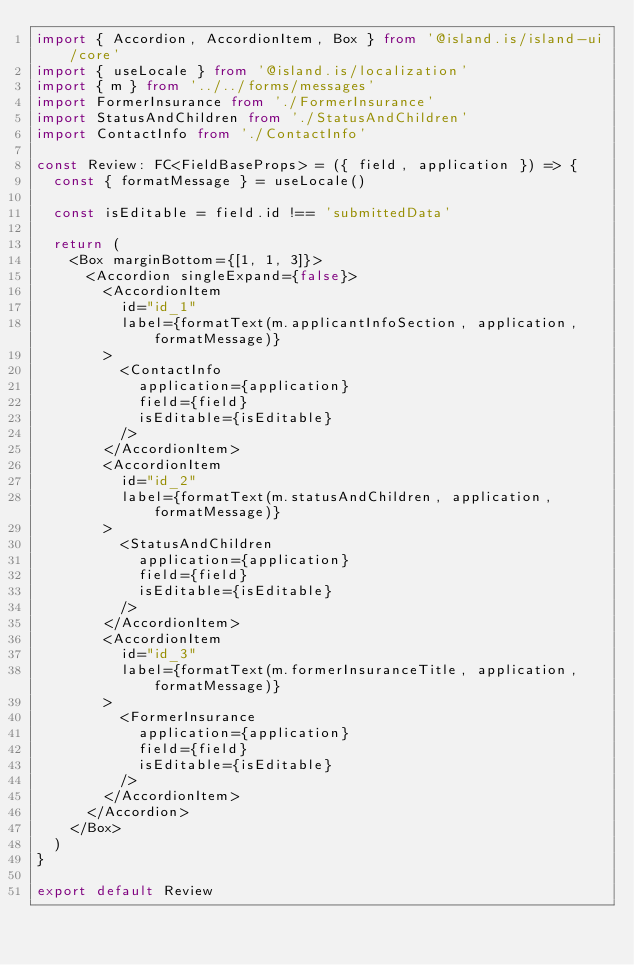Convert code to text. <code><loc_0><loc_0><loc_500><loc_500><_TypeScript_>import { Accordion, AccordionItem, Box } from '@island.is/island-ui/core'
import { useLocale } from '@island.is/localization'
import { m } from '../../forms/messages'
import FormerInsurance from './FormerInsurance'
import StatusAndChildren from './StatusAndChildren'
import ContactInfo from './ContactInfo'

const Review: FC<FieldBaseProps> = ({ field, application }) => {
  const { formatMessage } = useLocale()

  const isEditable = field.id !== 'submittedData'

  return (
    <Box marginBottom={[1, 1, 3]}>
      <Accordion singleExpand={false}>
        <AccordionItem
          id="id_1"
          label={formatText(m.applicantInfoSection, application, formatMessage)}
        >
          <ContactInfo
            application={application}
            field={field}
            isEditable={isEditable}
          />
        </AccordionItem>
        <AccordionItem
          id="id_2"
          label={formatText(m.statusAndChildren, application, formatMessage)}
        >
          <StatusAndChildren
            application={application}
            field={field}
            isEditable={isEditable}
          />
        </AccordionItem>
        <AccordionItem
          id="id_3"
          label={formatText(m.formerInsuranceTitle, application, formatMessage)}
        >
          <FormerInsurance
            application={application}
            field={field}
            isEditable={isEditable}
          />
        </AccordionItem>
      </Accordion>
    </Box>
  )
}

export default Review
</code> 